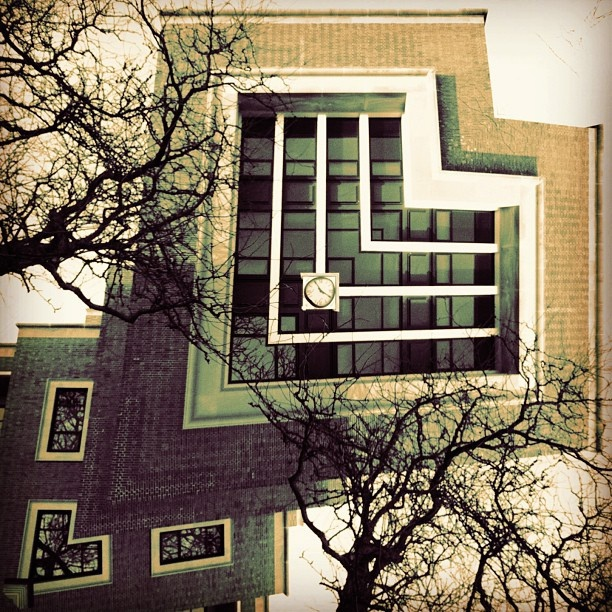Describe the objects in this image and their specific colors. I can see a clock in brown, beige, and tan tones in this image. 